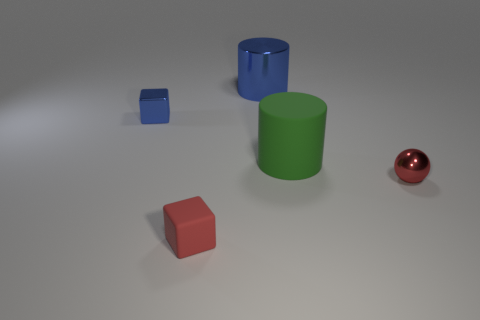Subtract all blue balls. Subtract all cyan blocks. How many balls are left? 1 Add 3 tiny purple cylinders. How many objects exist? 8 Subtract all spheres. How many objects are left? 4 Add 3 red things. How many red things exist? 5 Subtract 0 purple cylinders. How many objects are left? 5 Subtract all green shiny things. Subtract all tiny metallic things. How many objects are left? 3 Add 2 tiny matte objects. How many tiny matte objects are left? 3 